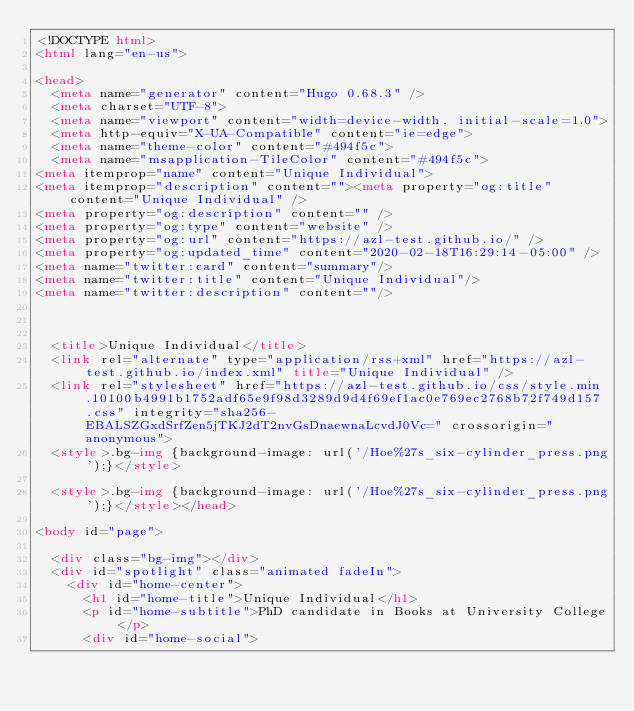Convert code to text. <code><loc_0><loc_0><loc_500><loc_500><_HTML_><!DOCTYPE html>
<html lang="en-us">

<head>
	<meta name="generator" content="Hugo 0.68.3" />
	<meta charset="UTF-8">
	<meta name="viewport" content="width=device-width, initial-scale=1.0">
	<meta http-equiv="X-UA-Compatible" content="ie=edge">
	<meta name="theme-color" content="#494f5c">
	<meta name="msapplication-TileColor" content="#494f5c">
<meta itemprop="name" content="Unique Individual">
<meta itemprop="description" content=""><meta property="og:title" content="Unique Individual" />
<meta property="og:description" content="" />
<meta property="og:type" content="website" />
<meta property="og:url" content="https://azl-test.github.io/" />
<meta property="og:updated_time" content="2020-02-18T16:29:14-05:00" />
<meta name="twitter:card" content="summary"/>
<meta name="twitter:title" content="Unique Individual"/>
<meta name="twitter:description" content=""/>


	
	<title>Unique Individual</title>
	<link rel="alternate" type="application/rss+xml" href="https://azl-test.github.io/index.xml" title="Unique Individual" />
	<link rel="stylesheet" href="https://azl-test.github.io/css/style.min.10100b4991b1752adf65e9f98d3289d9d4f69ef1ac0e769ec2768b72f749d157.css" integrity="sha256-EBALSZGxdSrfZen5jTKJ2dT2nvGsDnaewnaLcvdJ0Vc=" crossorigin="anonymous">
	<style>.bg-img {background-image: url('/Hoe%27s_six-cylinder_press.png');}</style>

	<style>.bg-img {background-image: url('/Hoe%27s_six-cylinder_press.png');}</style></head>

<body id="page">
	
	<div class="bg-img"></div>
	<div id="spotlight" class="animated fadeIn">
		<div id="home-center">
			<h1 id="home-title">Unique Individual</h1>
			<p id="home-subtitle">PhD candidate in Books at University College</p>
			<div id="home-social"></code> 